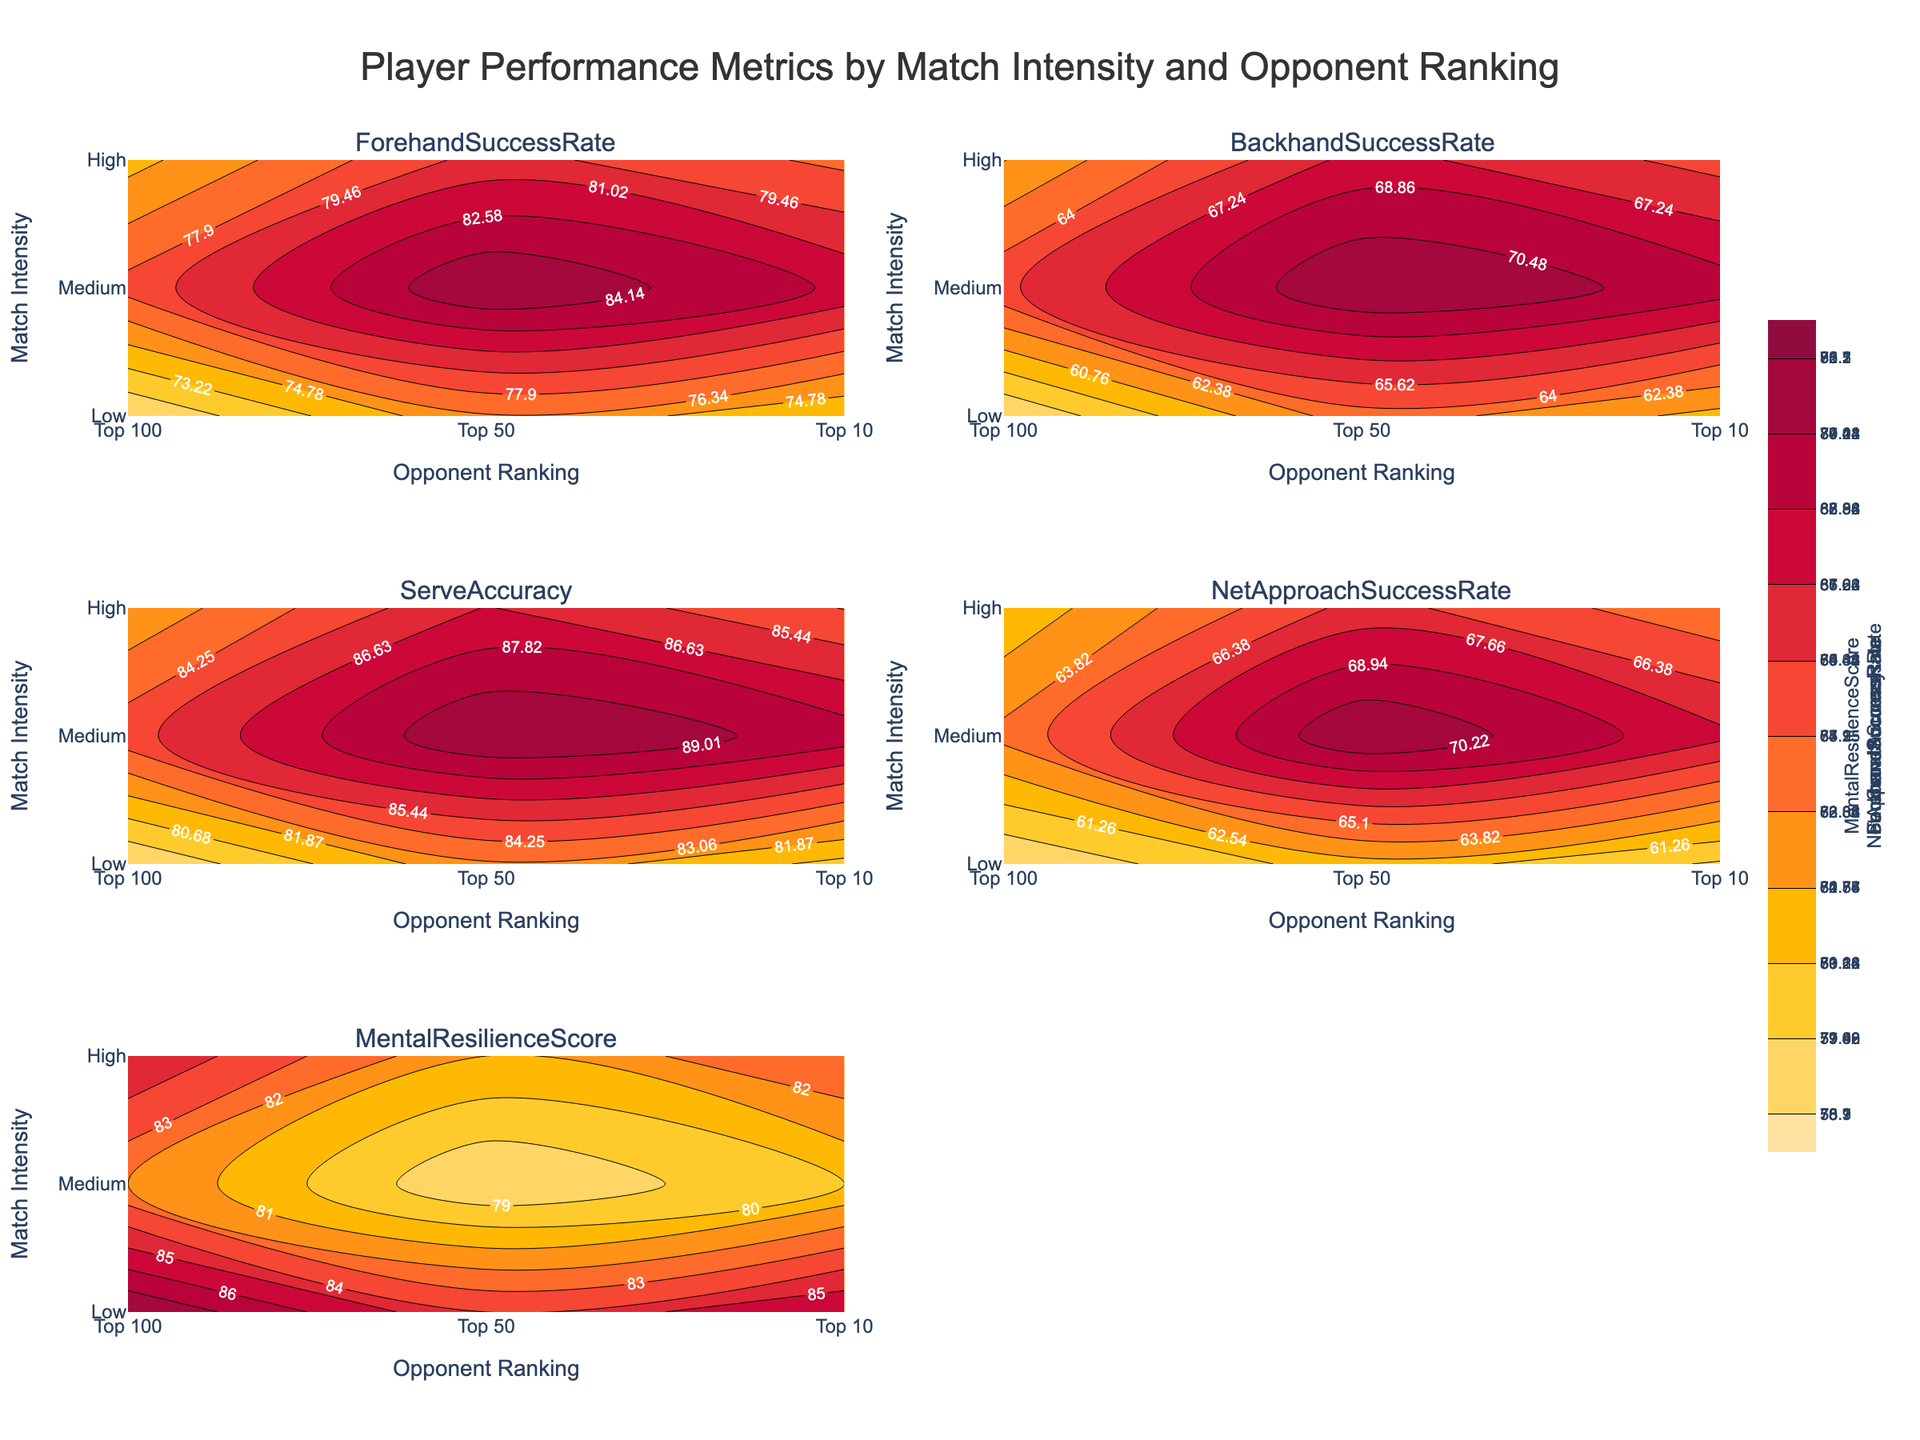What's the highest Mental Resilience Score for high-intensity matches? To identify the highest Mental Resilience Score for high-intensity matches, look at the top row of the Mental Resilience Score subplot. The high-intensity value corresponds to 88
Answer: 88 Which opponent ranking shows the lowest Serve Accuracy at high match intensity? For high match intensity, check the Serve Accuracy subplot and compare the values for 'Top 100', 'Top 50', and 'Top 10'. The lowest value appears at 'Top 10' with a value of 78.3
Answer: Top 10 How does Backhand Success Rate change from a low to a high match intensity against Top 50 opponents? Observe the Backhand Success Rate subplot. For 'Top 50' opponents, compare the values from low intensity (69.7) to high intensity (60.2). The rate decreases by 9.5
Answer: Decreases by 9.5 What is the difference in Net Approach Success Rate between low and high match intensity for Top 50 opponents? In the Net Approach Success Rate subplot, find the values for 'Top 50' opponents at low intensity (68.0) and high intensity (59.8). The difference is calculated as 68.0 - 59.8 = 8.2
Answer: 8.2 Which metric shows the greatest variation in values across different match intensities for Top 100 opponents? Examine each subplot for variations in the 'Top 100' opponent column. Determine the range for each metric and compare. Mental Resilience Score ranges from 78 to 84, with a difference of 6, which is the highest among the metrics
Answer: Mental Resilience Score In the Mental Resilience Score subplot, which match intensity shows the lowest score regardless of opponent ranking? In the Mental Resilience Score subplot, compare the scores across different intensities. The low-intensity category shows the values 82, 80, and 78, with 78 being the lowest
Answer: Low What trend can be observed for Forehand Success Rate as match intensity increases for Top 10 opponents? In the Forehand Success Rate subplot, observe the trend for 'Top 10' opponents as match intensity changes from low (78.5) to medium (74.2) to high (70.1). The rate decreases as intensity increases
Answer: Decreases How does Serve Accuracy for Medium match intensity compare between Top 100 and Top 50 opponents? In the Serve Accuracy subplot, observe the medium intensity values for 'Top 100' (86.7) and 'Top 50' (84.2). The difference is 86.7 - 84.2 = 2.5, showing higher accuracy for Top 100 opponents
Answer: Top 100 is higher by 2.5 For Top 10 opponents, which match intensity shows the greatest improvement in Serve Accuracy compared to Backhand Success Rate? Compare the differences between Serve Accuracy and Backhand Success Rate for each match intensity for 'Top 10' opponents. Calculate the improvements as follows:
- Low: 85.0 - 65.3 = 19.7
- Medium: 82.1 - 60.7 = 21.4
- High: 78.3 - 55.9 = 22.4
The greatest improvement is at high intensity (22.4)
Answer: High 